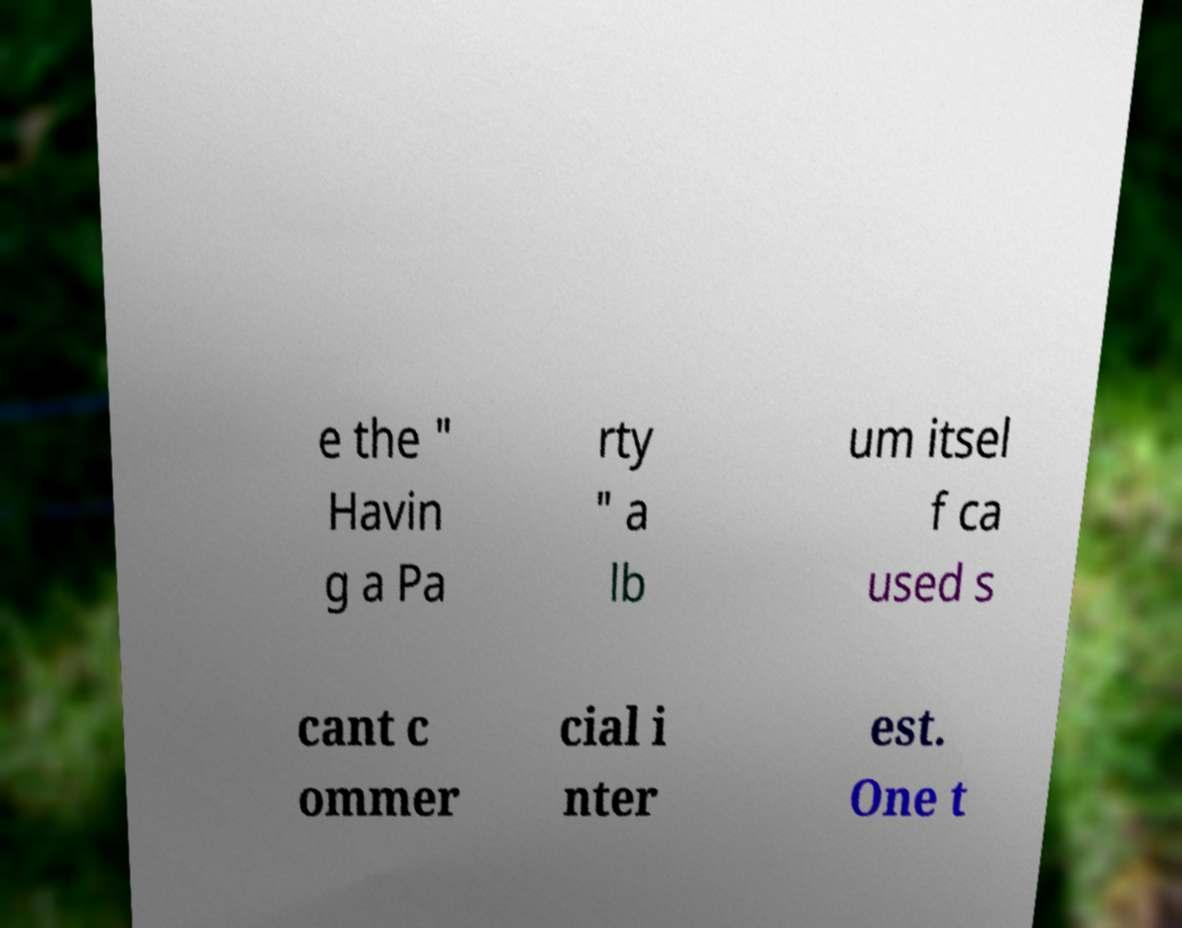There's text embedded in this image that I need extracted. Can you transcribe it verbatim? e the " Havin g a Pa rty " a lb um itsel f ca used s cant c ommer cial i nter est. One t 